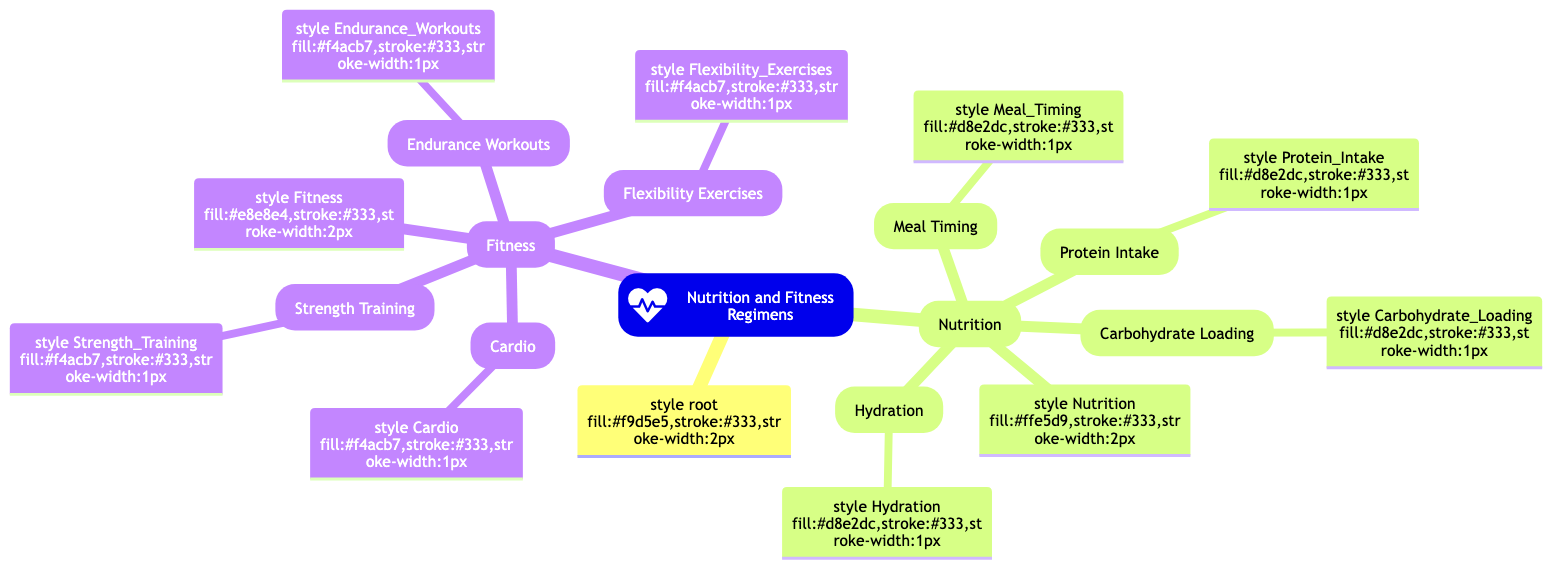What are the main categories in the diagram? The main categories in the diagram are "Nutrition" and "Fitness." These categories are the highest level of the mind map and serve as the primary areas of focus regarding nutrition and fitness regimens during active racing years.
Answer: Nutrition, Fitness How many nutrition subtopics are included? The diagram lists four nutrition subtopics: Carbohydrate Loading, Protein Intake, Hydration, and Meal Timing. Counting these, the total number is four.
Answer: 4 Which fitness component emphasizes cardiovascular health? The fitness component that emphasizes cardiovascular health is "Cardio." This node directly relates to exercises aimed at improving heart and lung endurance.
Answer: Cardio What is the relationship between Nutrition and Fitness? The diagram illustrates that Nutrition and Fitness are parallel categories under the main topic, indicating they are both essential elements of a holistic approach to health during racing years.
Answer: Parallel categories Which nutrition aspect is focused on water consumption? The nutrition aspect focused on water consumption is "Hydration." This refers specifically to maintaining adequate fluid intake to support racing performance and overall health.
Answer: Hydration What is included in the Fitness component alongside Cardio? Alongside Cardio, the Fitness component includes Strength Training, Flexibility Exercises, and Endurance Workouts. These three subtopics collectively enhance overall physical fitness.
Answer: Strength Training, Flexibility Exercises, Endurance Workouts How many total fitness subtopics are detailed in the diagram? The diagram details four fitness subtopics: Cardio, Strength Training, Flexibility Exercises, and Endurance Workouts, resulting in a total of four subtopics under the Fitness category.
Answer: 4 Which nutrition subtopic is focused on meal preparation timing? The nutrition subtopic focused on meal preparation timing is "Meal Timing." This refers to the strategic scheduling of food intake around training and racing events.
Answer: Meal Timing What is the main visual structure used in the diagram? The main visual structure used in the diagram is a mind map. This structure organizes information hierarchically, connecting related concepts in a visual format.
Answer: Mind map 